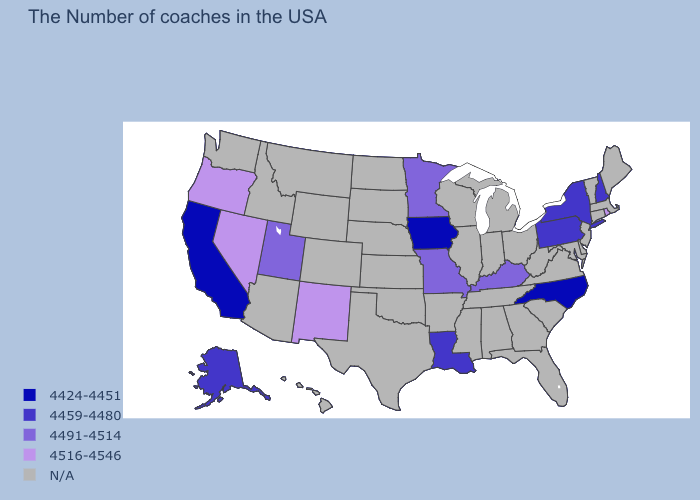Among the states that border Maryland , which have the highest value?
Quick response, please. Pennsylvania. What is the value of New Mexico?
Concise answer only. 4516-4546. What is the value of North Dakota?
Concise answer only. N/A. How many symbols are there in the legend?
Quick response, please. 5. How many symbols are there in the legend?
Be succinct. 5. Name the states that have a value in the range 4424-4451?
Give a very brief answer. North Carolina, Iowa, California. Name the states that have a value in the range 4516-4546?
Give a very brief answer. Rhode Island, New Mexico, Nevada, Oregon. Does Iowa have the lowest value in the USA?
Answer briefly. Yes. Does the first symbol in the legend represent the smallest category?
Quick response, please. Yes. What is the value of Arkansas?
Keep it brief. N/A. What is the highest value in the USA?
Short answer required. 4516-4546. Name the states that have a value in the range 4459-4480?
Short answer required. New Hampshire, New York, Pennsylvania, Louisiana, Alaska. What is the highest value in the USA?
Be succinct. 4516-4546. 